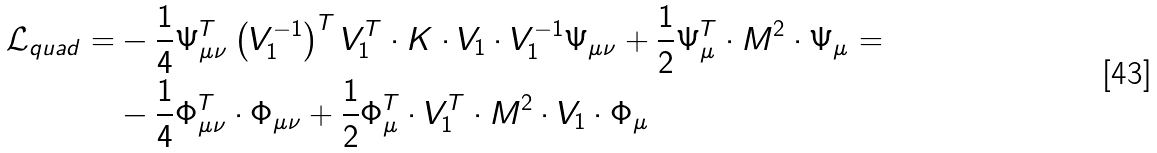<formula> <loc_0><loc_0><loc_500><loc_500>\mathcal { L } _ { q u a d } = & - \frac { 1 } { 4 } \Psi _ { \mu \nu } ^ { T } \left ( V _ { 1 } ^ { - 1 } \right ) ^ { T } V _ { 1 } ^ { T } \cdot K \cdot V _ { 1 } \cdot V _ { 1 } ^ { - 1 } \Psi _ { \mu \nu } + \frac { 1 } { 2 } \Psi _ { \mu } ^ { T } \cdot M ^ { 2 } \cdot \Psi _ { \mu } = \\ & - \frac { 1 } { 4 } \Phi _ { \mu \nu } ^ { T } \cdot \Phi _ { \mu \nu } + \frac { 1 } { 2 } \Phi _ { \mu } ^ { T } \cdot V _ { 1 } ^ { T } \cdot M ^ { 2 } \cdot V _ { 1 } \cdot \Phi _ { \mu }</formula> 